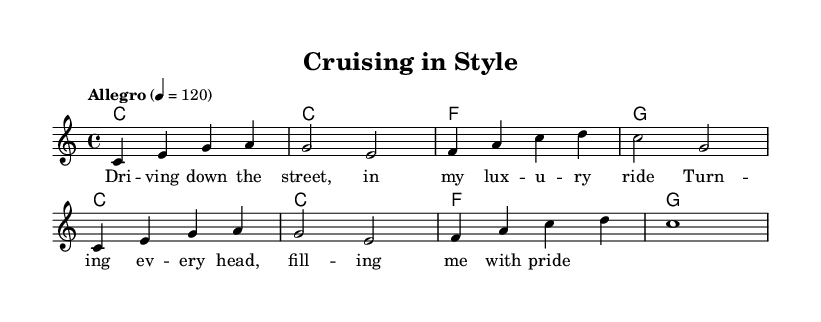What is the key signature of this music? The key signature is indicated at the beginning of the sheet music, showing no sharps or flats. This corresponds to C major.
Answer: C major What is the time signature of this piece? The time signature is found at the beginning of the score, displayed as a fraction. It shows that there are four beats per measure.
Answer: 4/4 What is the tempo marking for this song? The tempo is provided at the start of the music and is indicated by the word "Allegro" along with a metronome marking of 120 beats per minute.
Answer: Allegro, 120 How many measures are in the melody? To find the number of measures, we count the individual segments separated by vertical lines. The melody has eight measures in total.
Answer: 8 What chords are used in the harmony section? The chords in the harmony section are listed in a chord mode format, and they include C, F, and G. Each chord appears after its respective measure.
Answer: C, F, G What is the lyrical theme of this piece? By reading the lyrics written below the melody, we can identify the central theme, which focuses on luxury and pride while driving.
Answer: Luxury and pride 